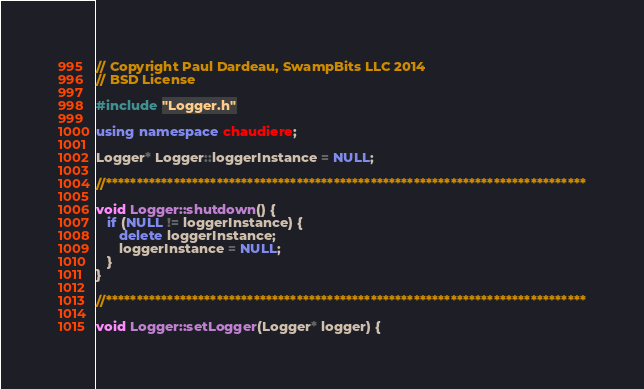<code> <loc_0><loc_0><loc_500><loc_500><_C++_>// Copyright Paul Dardeau, SwampBits LLC 2014
// BSD License

#include "Logger.h"

using namespace chaudiere;

Logger* Logger::loggerInstance = NULL;

//******************************************************************************

void Logger::shutdown() {
   if (NULL != loggerInstance) {
      delete loggerInstance;
      loggerInstance = NULL;
   }
}

//******************************************************************************

void Logger::setLogger(Logger* logger) {</code> 